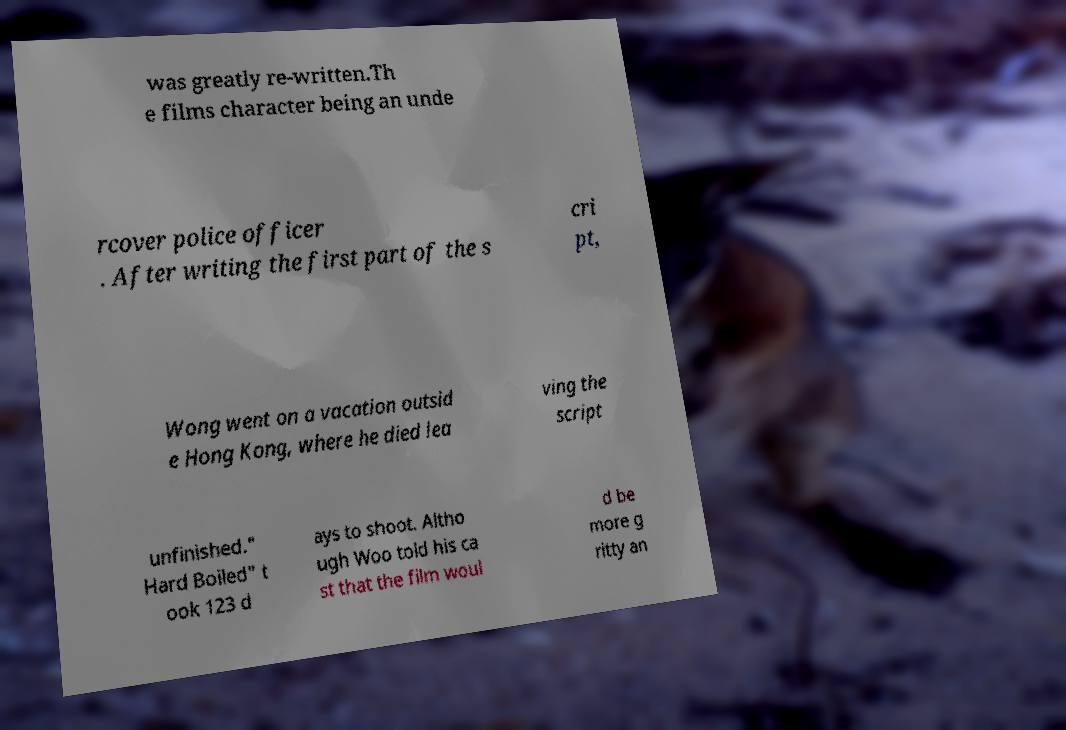Please read and relay the text visible in this image. What does it say? was greatly re-written.Th e films character being an unde rcover police officer . After writing the first part of the s cri pt, Wong went on a vacation outsid e Hong Kong, where he died lea ving the script unfinished." Hard Boiled" t ook 123 d ays to shoot. Altho ugh Woo told his ca st that the film woul d be more g ritty an 